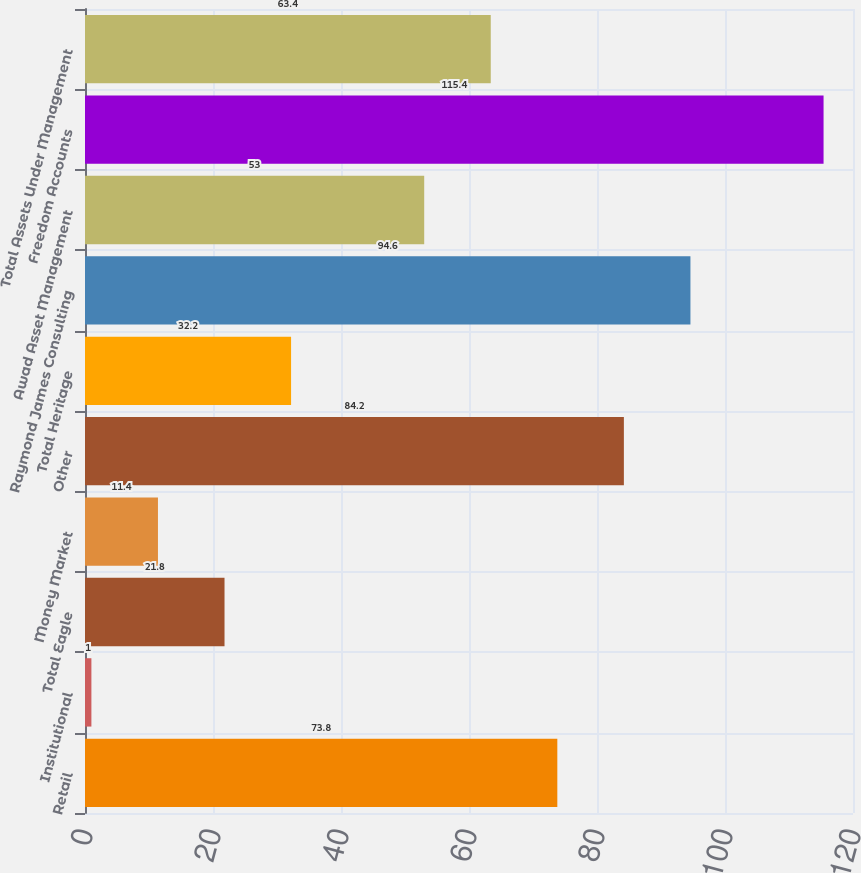Convert chart to OTSL. <chart><loc_0><loc_0><loc_500><loc_500><bar_chart><fcel>Retail<fcel>Institutional<fcel>Total Eagle<fcel>Money Market<fcel>Other<fcel>Total Heritage<fcel>Raymond James Consulting<fcel>Awad Asset Management<fcel>Freedom Accounts<fcel>Total Assets Under Management<nl><fcel>73.8<fcel>1<fcel>21.8<fcel>11.4<fcel>84.2<fcel>32.2<fcel>94.6<fcel>53<fcel>115.4<fcel>63.4<nl></chart> 